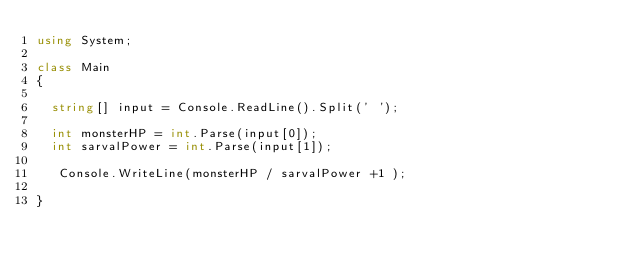<code> <loc_0><loc_0><loc_500><loc_500><_C#_>using System;

class Main 
{
 
  string[] input = Console.ReadLine().Split(' ');
 
  int monsterHP = int.Parse(input[0]);
  int sarvalPower = int.Parse(input[1]);
  
   Console.WriteLine(monsterHP / sarvalPower +1 );
  
}</code> 